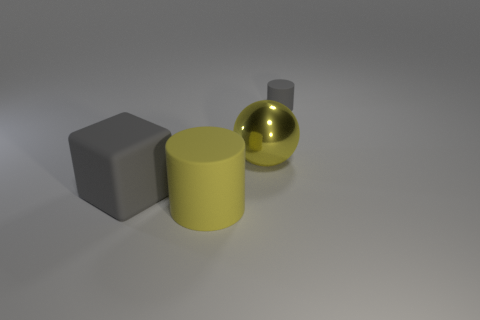Add 1 gray cylinders. How many objects exist? 5 Subtract 0 green balls. How many objects are left? 4 Subtract all balls. How many objects are left? 3 Subtract 1 spheres. How many spheres are left? 0 Subtract all purple cylinders. Subtract all blue cubes. How many cylinders are left? 2 Subtract all blue balls. How many gray cylinders are left? 1 Subtract all gray things. Subtract all big cubes. How many objects are left? 1 Add 3 gray cylinders. How many gray cylinders are left? 4 Add 3 tiny gray matte cylinders. How many tiny gray matte cylinders exist? 4 